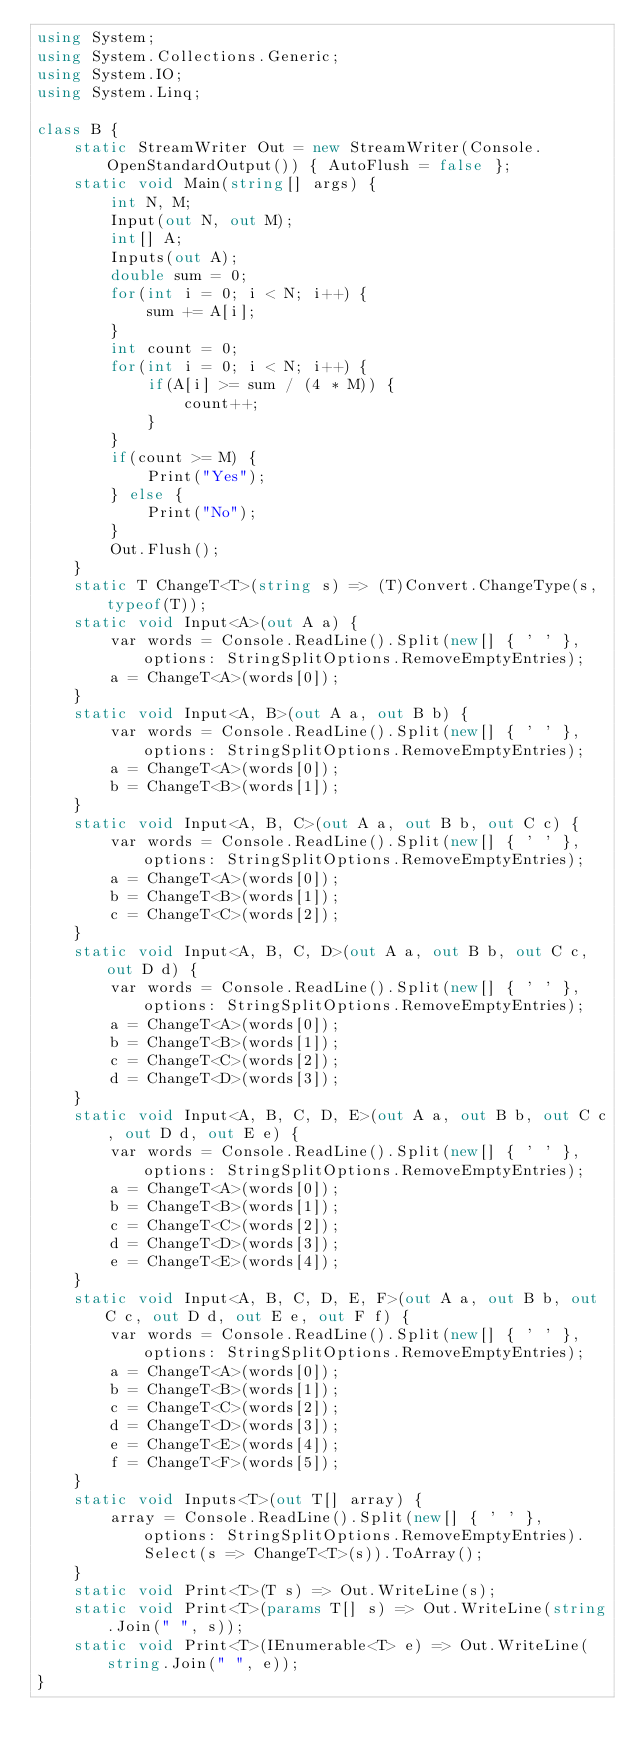Convert code to text. <code><loc_0><loc_0><loc_500><loc_500><_C#_>using System;
using System.Collections.Generic;
using System.IO;
using System.Linq;

class B {
    static StreamWriter Out = new StreamWriter(Console.OpenStandardOutput()) { AutoFlush = false };
    static void Main(string[] args) {
        int N, M;
        Input(out N, out M);
        int[] A;
        Inputs(out A);
        double sum = 0;
        for(int i = 0; i < N; i++) {
            sum += A[i];
        }
        int count = 0;
        for(int i = 0; i < N; i++) {
            if(A[i] >= sum / (4 * M)) {
                count++;
            }
        }
        if(count >= M) {
            Print("Yes");
        } else {
            Print("No");
        }
        Out.Flush();
    }
    static T ChangeT<T>(string s) => (T)Convert.ChangeType(s, typeof(T));
    static void Input<A>(out A a) {
        var words = Console.ReadLine().Split(new[] { ' ' }, options: StringSplitOptions.RemoveEmptyEntries);
        a = ChangeT<A>(words[0]);
    }
    static void Input<A, B>(out A a, out B b) {
        var words = Console.ReadLine().Split(new[] { ' ' }, options: StringSplitOptions.RemoveEmptyEntries);
        a = ChangeT<A>(words[0]);
        b = ChangeT<B>(words[1]);
    }
    static void Input<A, B, C>(out A a, out B b, out C c) {
        var words = Console.ReadLine().Split(new[] { ' ' }, options: StringSplitOptions.RemoveEmptyEntries);
        a = ChangeT<A>(words[0]);
        b = ChangeT<B>(words[1]);
        c = ChangeT<C>(words[2]);
    }
    static void Input<A, B, C, D>(out A a, out B b, out C c, out D d) {
        var words = Console.ReadLine().Split(new[] { ' ' }, options: StringSplitOptions.RemoveEmptyEntries);
        a = ChangeT<A>(words[0]);
        b = ChangeT<B>(words[1]);
        c = ChangeT<C>(words[2]);
        d = ChangeT<D>(words[3]);
    }
    static void Input<A, B, C, D, E>(out A a, out B b, out C c, out D d, out E e) {
        var words = Console.ReadLine().Split(new[] { ' ' }, options: StringSplitOptions.RemoveEmptyEntries);
        a = ChangeT<A>(words[0]);
        b = ChangeT<B>(words[1]);
        c = ChangeT<C>(words[2]);
        d = ChangeT<D>(words[3]);
        e = ChangeT<E>(words[4]);
    }
    static void Input<A, B, C, D, E, F>(out A a, out B b, out C c, out D d, out E e, out F f) {
        var words = Console.ReadLine().Split(new[] { ' ' }, options: StringSplitOptions.RemoveEmptyEntries);
        a = ChangeT<A>(words[0]);
        b = ChangeT<B>(words[1]);
        c = ChangeT<C>(words[2]);
        d = ChangeT<D>(words[3]);
        e = ChangeT<E>(words[4]);
        f = ChangeT<F>(words[5]);
    }
    static void Inputs<T>(out T[] array) {
        array = Console.ReadLine().Split(new[] { ' ' }, options: StringSplitOptions.RemoveEmptyEntries).Select(s => ChangeT<T>(s)).ToArray();
    }
    static void Print<T>(T s) => Out.WriteLine(s);
    static void Print<T>(params T[] s) => Out.WriteLine(string.Join(" ", s));
    static void Print<T>(IEnumerable<T> e) => Out.WriteLine(string.Join(" ", e));
}</code> 